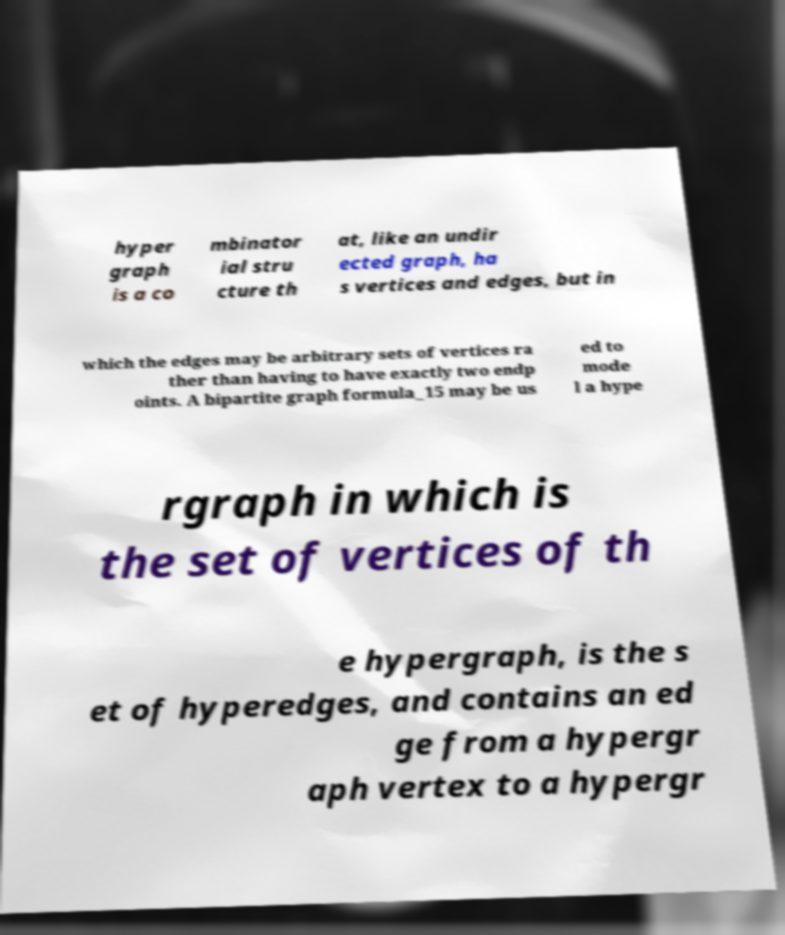Could you assist in decoding the text presented in this image and type it out clearly? hyper graph is a co mbinator ial stru cture th at, like an undir ected graph, ha s vertices and edges, but in which the edges may be arbitrary sets of vertices ra ther than having to have exactly two endp oints. A bipartite graph formula_15 may be us ed to mode l a hype rgraph in which is the set of vertices of th e hypergraph, is the s et of hyperedges, and contains an ed ge from a hypergr aph vertex to a hypergr 